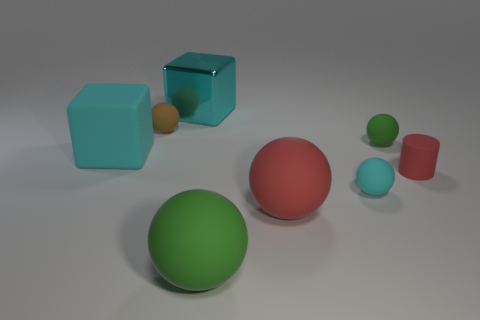Subtract all small cyan rubber spheres. How many spheres are left? 4 Subtract all gray cylinders. How many green balls are left? 2 Subtract all cyan balls. How many balls are left? 4 Subtract 4 spheres. How many spheres are left? 1 Subtract all gray spheres. Subtract all cyan cubes. How many spheres are left? 5 Add 2 yellow metallic spheres. How many objects exist? 10 Subtract all balls. How many objects are left? 3 Subtract all large matte cylinders. Subtract all cylinders. How many objects are left? 7 Add 5 tiny cyan matte things. How many tiny cyan matte things are left? 6 Add 1 large red balls. How many large red balls exist? 2 